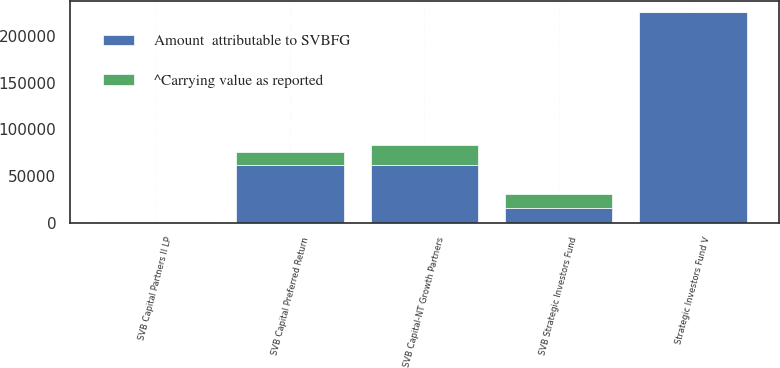Convert chart. <chart><loc_0><loc_0><loc_500><loc_500><stacked_bar_chart><ecel><fcel>SVB Strategic Investors Fund<fcel>Strategic Investors Fund V<fcel>SVB Capital Preferred Return<fcel>SVB Capital-NT Growth Partners<fcel>SVB Capital Partners II LP<nl><fcel>Amount  attributable to SVBFG<fcel>15841<fcel>226111<fcel>62110<fcel>61973<fcel>302<nl><fcel>^Carrying value as reported<fcel>14564<fcel>350<fcel>13386<fcel>21006<fcel>15<nl></chart> 